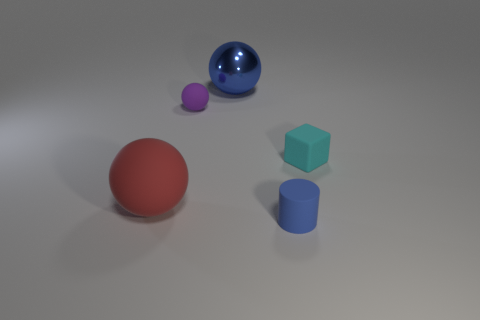Add 3 big red shiny cylinders. How many objects exist? 8 Subtract all balls. How many objects are left? 2 Subtract all small balls. Subtract all tiny purple matte things. How many objects are left? 3 Add 4 big blue spheres. How many big blue spheres are left? 5 Add 5 matte blocks. How many matte blocks exist? 6 Subtract 0 green balls. How many objects are left? 5 